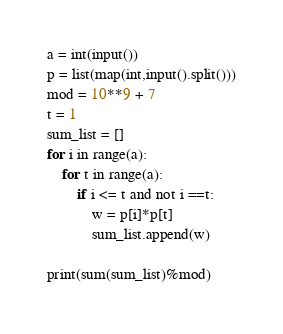Convert code to text. <code><loc_0><loc_0><loc_500><loc_500><_Python_>a = int(input())
p = list(map(int,input().split()))
mod = 10**9 + 7
t = 1
sum_list = []
for i in range(a):
    for t in range(a):
        if i <= t and not i ==t:
            w = p[i]*p[t]
            sum_list.append(w)

print(sum(sum_list)%mod)</code> 